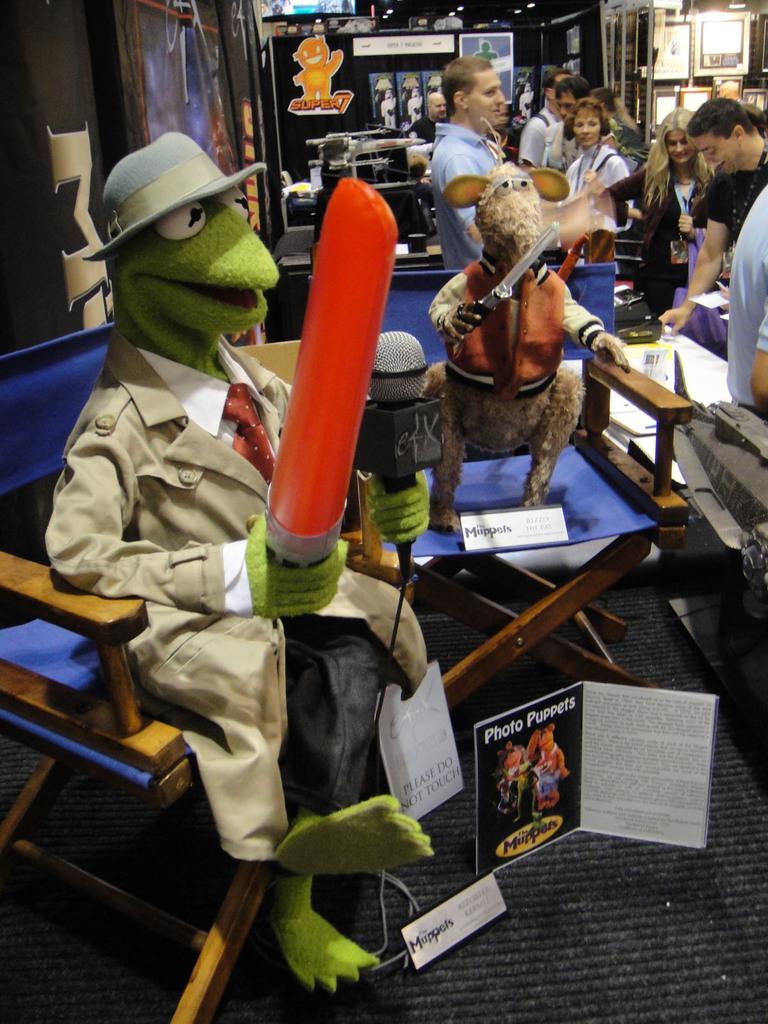Describe this image in one or two sentences. In the foreground of this image, there are two toys on the chairs holding few objects and a mic. We can also see few posts and boards. In the background, there are few people standing, banners, frames on the wall, lights to the ceiling and few more objects in the background. 